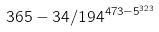<formula> <loc_0><loc_0><loc_500><loc_500>3 6 5 - 3 4 / 1 9 4 ^ { 4 7 3 - 5 ^ { 3 2 3 } }</formula> 